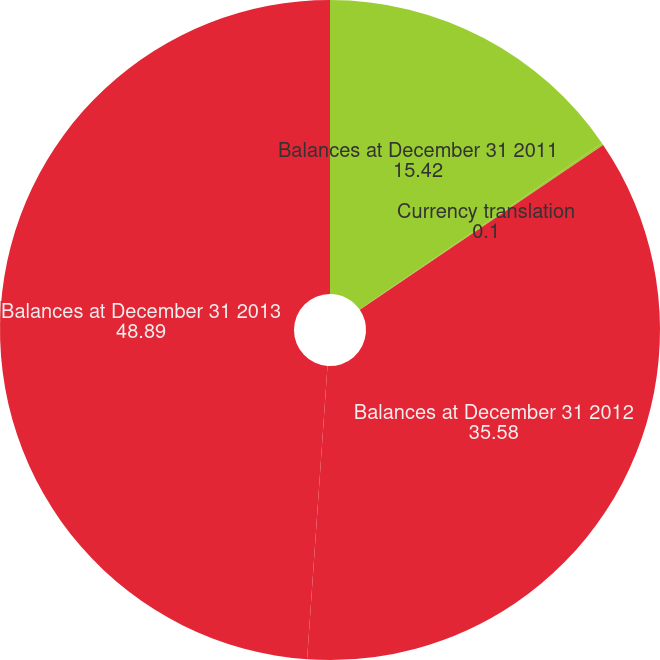<chart> <loc_0><loc_0><loc_500><loc_500><pie_chart><fcel>Balances at December 31 2011<fcel>Currency translation<fcel>Balances at December 31 2012<fcel>Balances at December 31 2013<nl><fcel>15.42%<fcel>0.1%<fcel>35.58%<fcel>48.89%<nl></chart> 